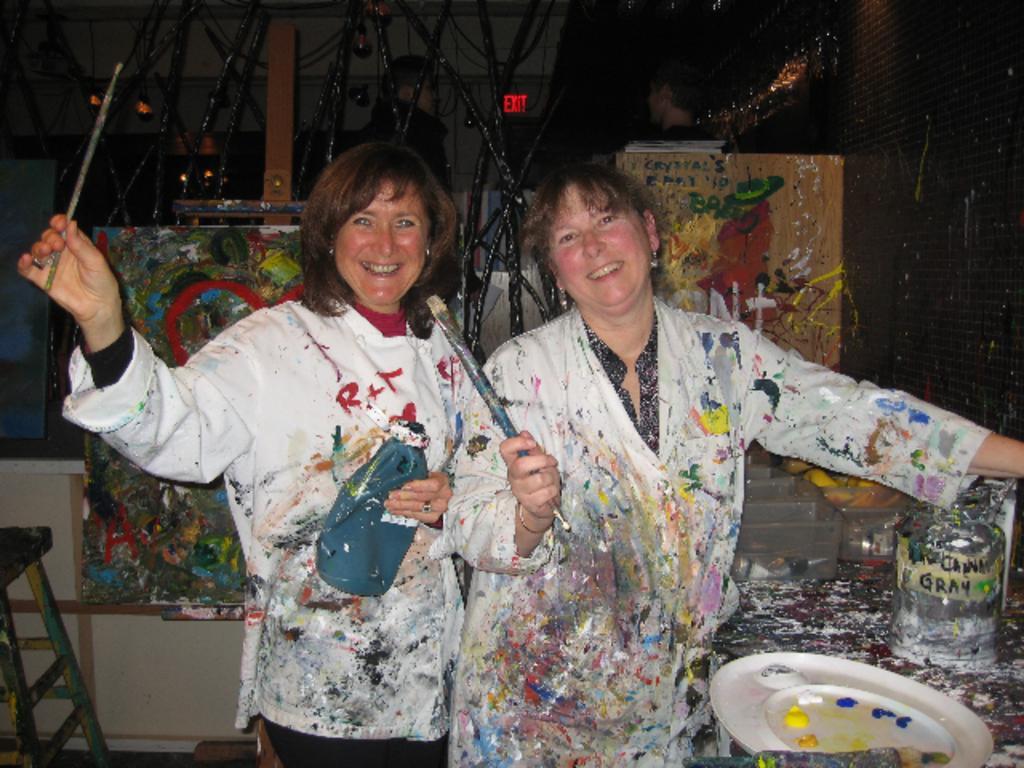Can you describe this image briefly? In this image in the foreground there are two women who are standing and smiling, and they are holding brushes. And they are wearing t shirts, on the t shirts there is painting. And on the right side of the image, there is a plate. On the plate there are some colors, and some objects and table. And in the background there are some boards, lights and some other objects. 